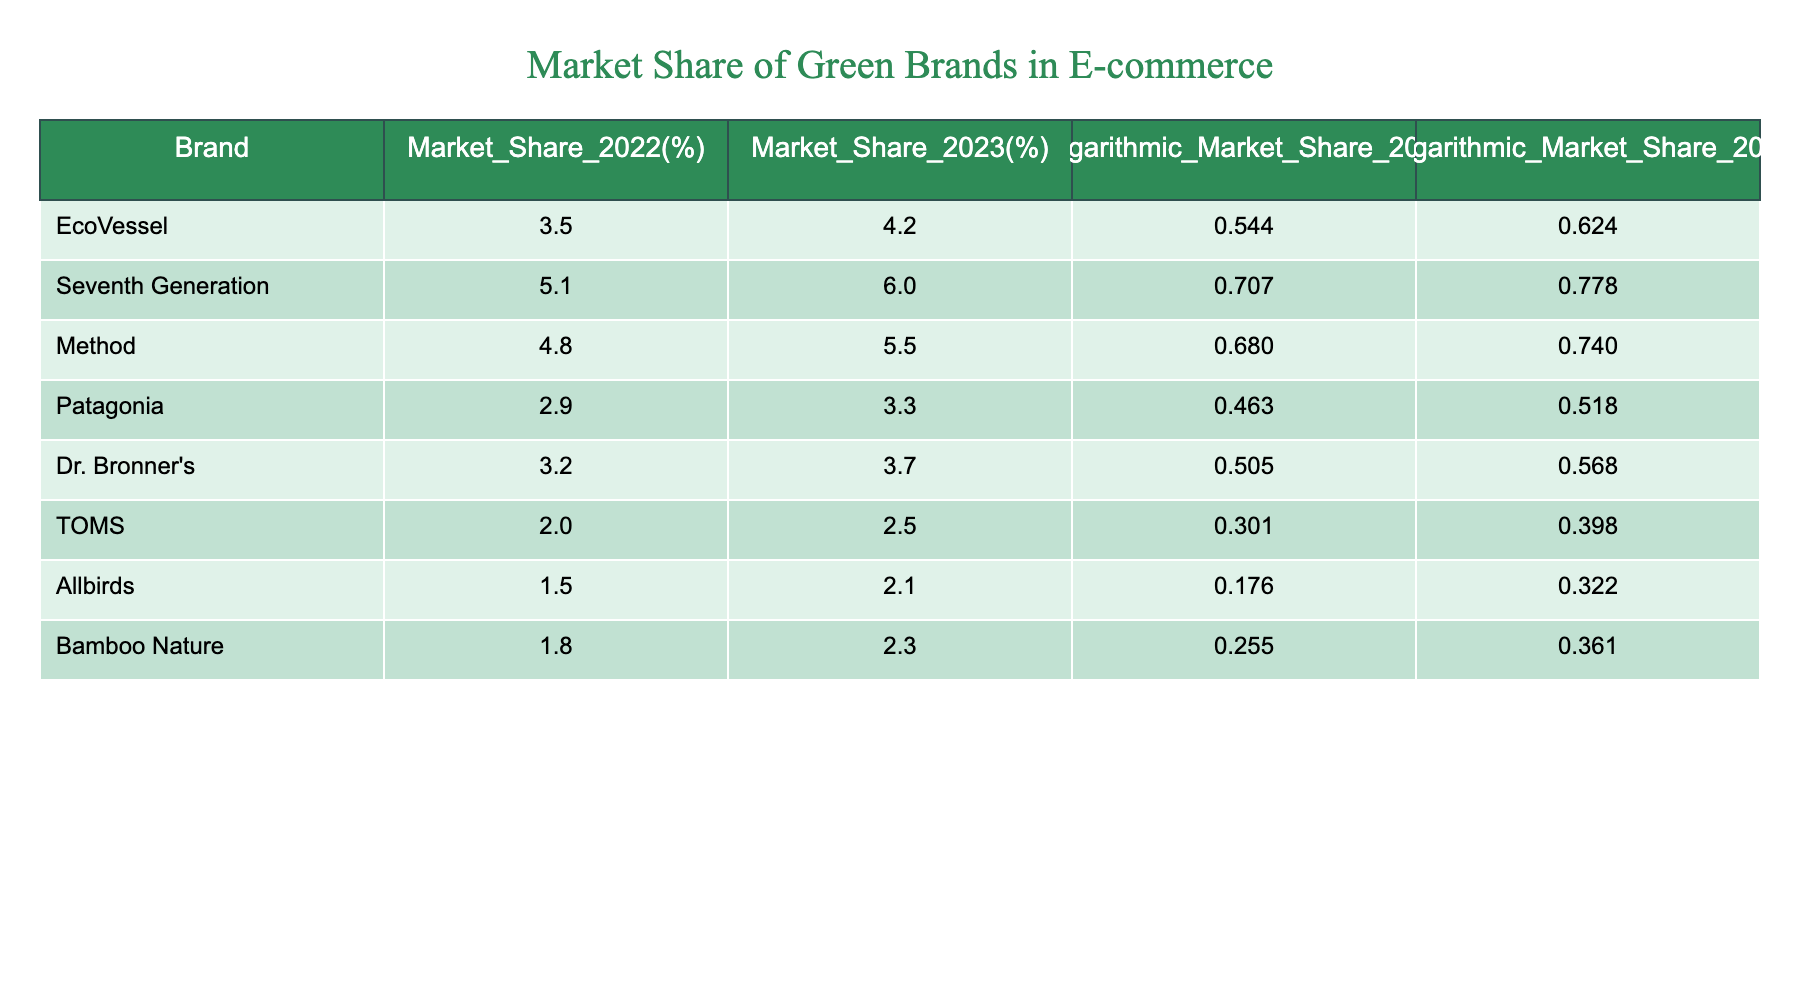What was the market share of EcoVessel in 2023? The table shows that EcoVessel had a market share of 4.2% in 2023, which is directly listed in the column for Market_Share_2023.
Answer: 4.2% Which brand had the highest market share in 2023? By comparing the values in the Market_Share_2023 column, Seventh Generation holds the highest market share at 6.0%.
Answer: Seventh Generation What is the difference in market share for Method from 2022 to 2023? The difference can be calculated by subtracting the 2022 market share (4.8%) from the 2023 market share (5.5%), which gives 5.5% - 4.8% = 0.7%.
Answer: 0.7% Is the logarithmic market share for Allbirds higher in 2023 than in 2022? The logarithmic values are 0.322 for 2023 and 0.176 for 2022. Since 0.322 is greater than 0.176, it is true that the logarithmic market share for Allbirds increased.
Answer: Yes What is the average market share of all the brands for 2023? To calculate the average, we sum the 2023 market shares (4.2 + 6.0 + 5.5 + 3.3 + 3.7 + 2.5 + 2.1 + 2.3) which equals 29.6%, and then divide by 8 (the number of brands), giving us an average of 29.6% / 8 = 3.7%.
Answer: 3.7% Which brand experienced the largest percentage increase in market share from 2022 to 2023? To find the largest percentage increase, we calculate the difference for each brand, then divide by the 2022 value and multiply by 100. For example, EcoVessel (4.2 - 3.5) / 3.5 * 100 = 20%, and similarly for others. The calculations show that Seventh Generation had the largest increase of approximately 17.6%.
Answer: Seventh Generation Are there any brands that have a logarithmic market share of less than 0.5 in 2023? Looking at the Logarithmic_Market_Share_2023, only Allbirds (0.322) and TOMS (0.398) are below 0.5, so it is true that some brands have a logarithmic market share less than 0.5.
Answer: Yes What is the total logarithmic market share of all brands in 2023? By summing the logarithmic values for all brands in 2023 (0.624 + 0.778 + 0.740 + 0.518 + 0.568 + 0.398 + 0.322 + 0.361), the total equals 4.819.
Answer: 4.819 